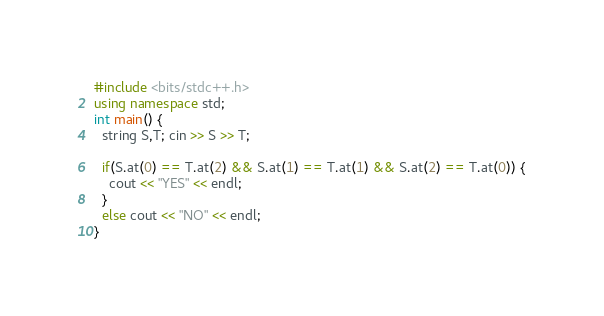Convert code to text. <code><loc_0><loc_0><loc_500><loc_500><_C++_>#include <bits/stdc++.h>
using namespace std;
int main() {
  string S,T; cin >> S >> T;
  
  if(S.at(0) == T.at(2) && S.at(1) == T.at(1) && S.at(2) == T.at(0)) {
    cout << "YES" << endl; 
  }
  else cout << "NO" << endl;    
}</code> 